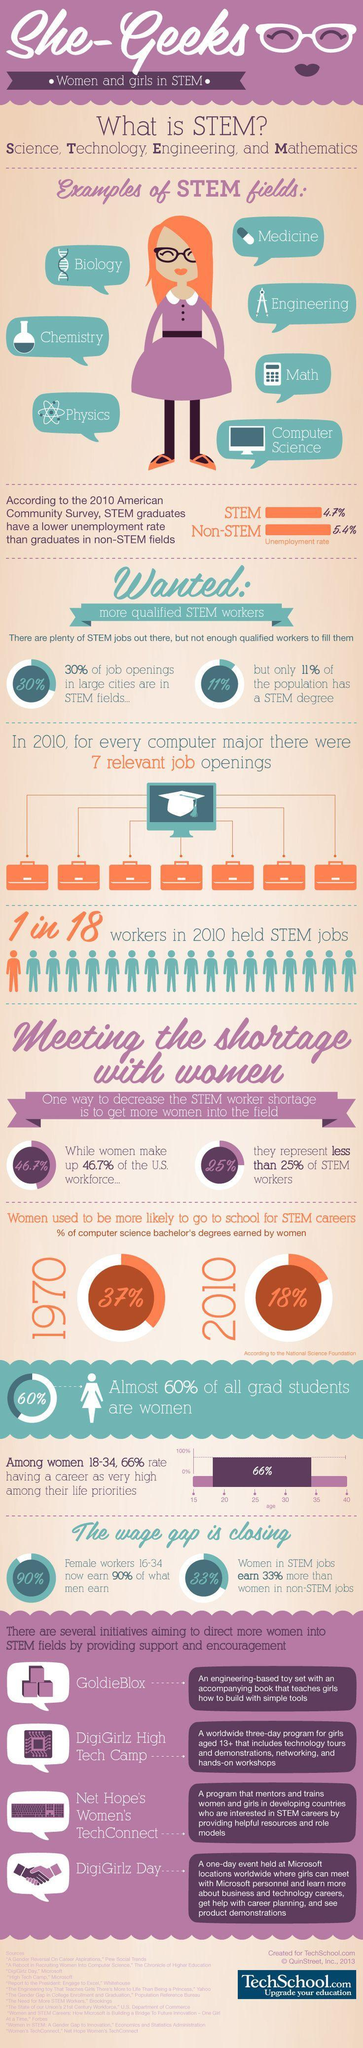What is the percentage of women upskilling themselves to take up a STEM career in 2010, 37%, 18%, or 60%?
Answer the question with a short phrase. 18% What is percentage gap between women choosing stem field and other careers? 21.7% 